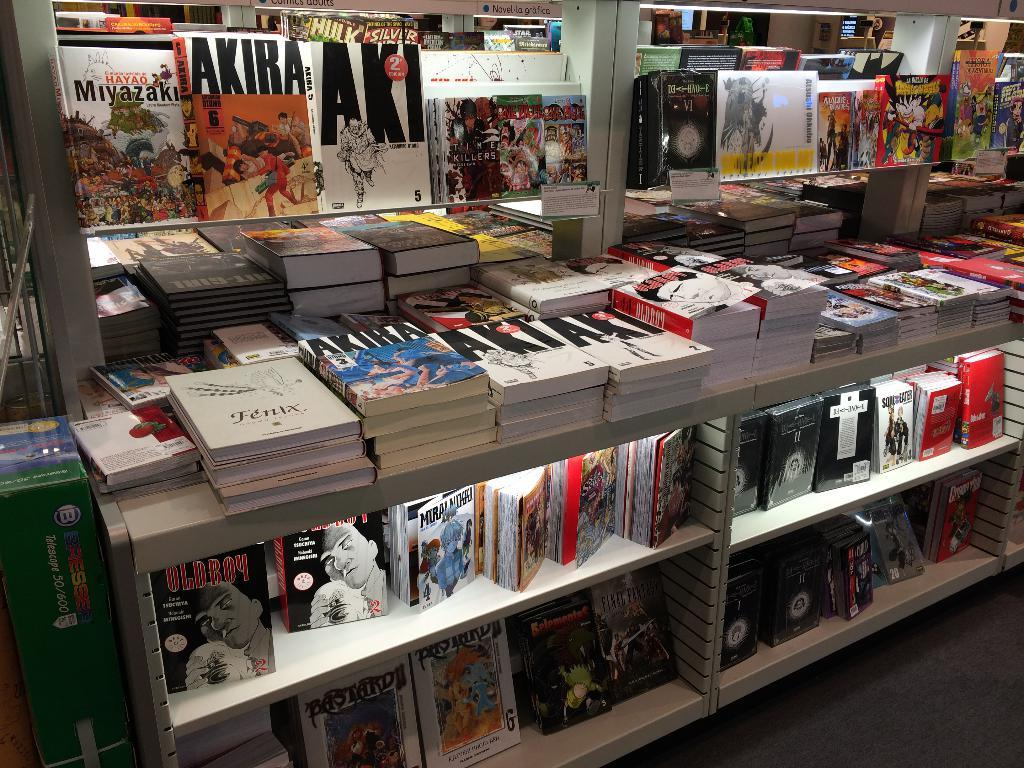<image>
Provide a brief description of the given image. Several copies of AKIRA are on the shelves at this bookstore. 